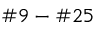<formula> <loc_0><loc_0><loc_500><loc_500>\# 9 - \# 2 5</formula> 